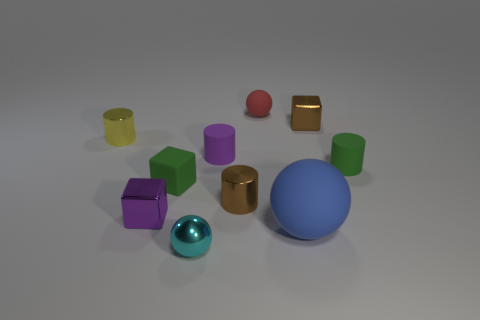Is there anything else that is the same size as the blue ball?
Make the answer very short. No. There is a rubber cylinder left of the tiny green cylinder; is its size the same as the metallic cube that is behind the tiny yellow object?
Offer a very short reply. Yes. How many objects are tiny yellow rubber cubes or tiny shiny cylinders?
Offer a very short reply. 2. Are there any large green metallic things that have the same shape as the small cyan metallic object?
Keep it short and to the point. No. Are there fewer purple metallic blocks than brown matte blocks?
Your answer should be very brief. No. Is the small yellow thing the same shape as the small purple rubber thing?
Ensure brevity in your answer.  Yes. How many objects are either purple rubber cylinders or tiny metallic blocks on the right side of the red object?
Make the answer very short. 2. How many big gray rubber objects are there?
Offer a very short reply. 0. Is there a red matte thing that has the same size as the red matte ball?
Your answer should be compact. No. Are there fewer small balls that are to the right of the yellow metal object than small cubes?
Make the answer very short. Yes. 